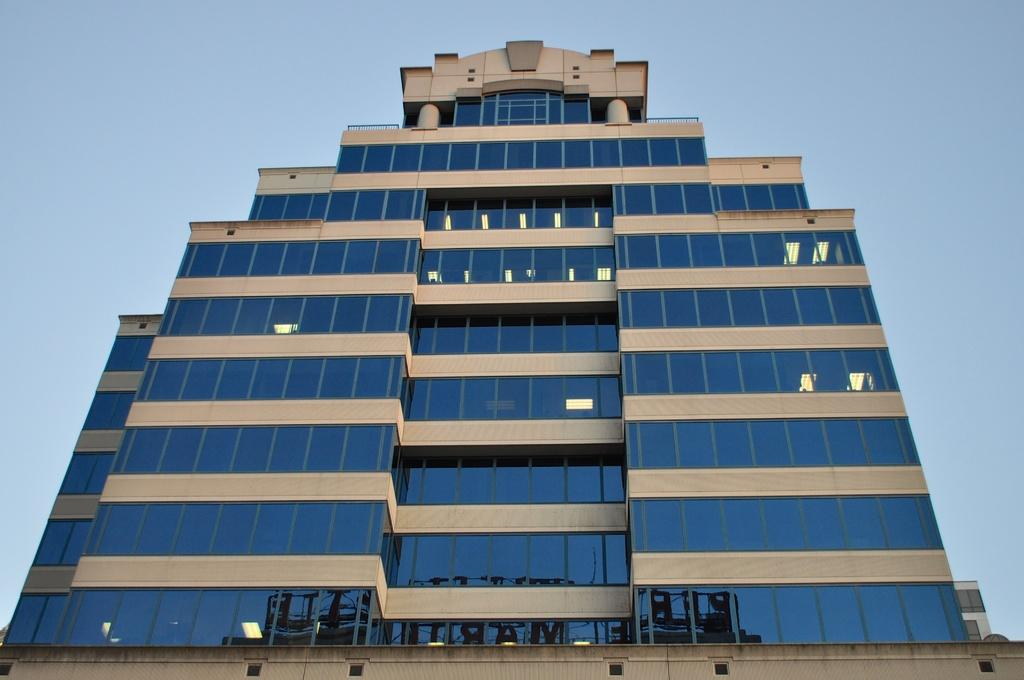What is the main subject in the foreground of the picture? There is a building in the foreground of the picture. What can be seen in the background of the picture? The provided facts do not mention any background elements. However, we can infer that the sky is visible in the background, as it is mentioned that the sky is clear. What is the weather like in the image? The clear sky suggests that the weather is likely sunny and clear. How many sisters are playing in the field in the image? There are no sisters or fields present in the image; it features a building and a clear sky. 